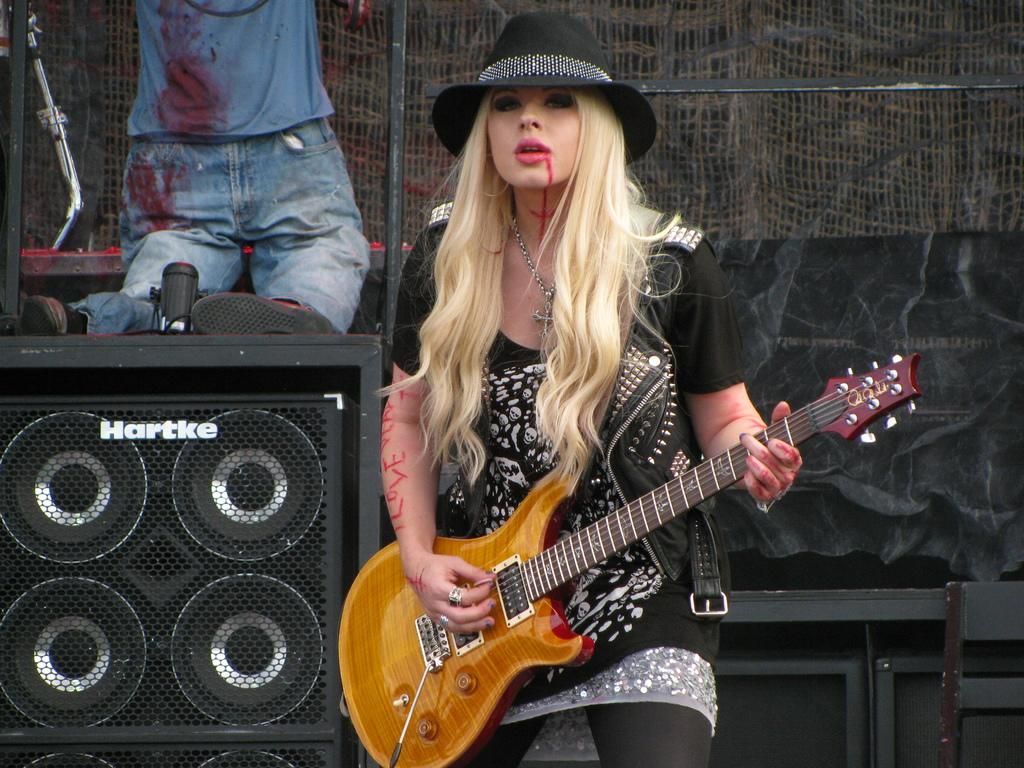Who is the main subject in the image? There is a girl in the image. What is the girl doing in the image? The girl is playing the guitar. Can you describe the girl's attire in the image? The girl is wearing a hat and has a chain around her neck. What can be seen in the background of the image? There are speakers and a net in the background of the image, as well as a man. What brand of toothpaste is the girl using in the image? There is no toothpaste present in the image, as the girl is playing the guitar and not engaged in any activity related to toothpaste. 